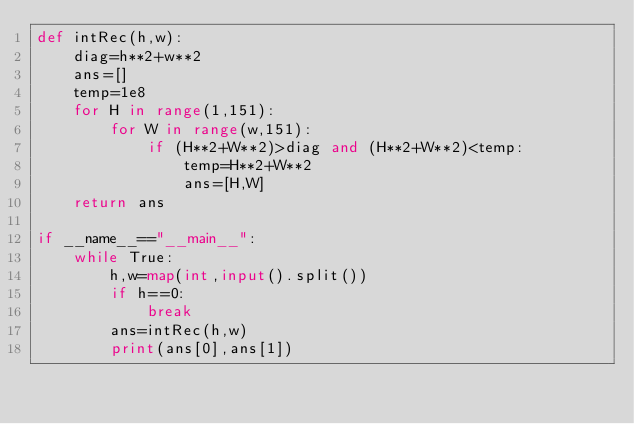Convert code to text. <code><loc_0><loc_0><loc_500><loc_500><_Python_>def intRec(h,w):
    diag=h**2+w**2
    ans=[]
    temp=1e8
    for H in range(1,151):
        for W in range(w,151):
            if (H**2+W**2)>diag and (H**2+W**2)<temp:
                temp=H**2+W**2
                ans=[H,W]
    return ans

if __name__=="__main__":
    while True:
        h,w=map(int,input().split())
        if h==0:
            break
        ans=intRec(h,w)
        print(ans[0],ans[1])
</code> 